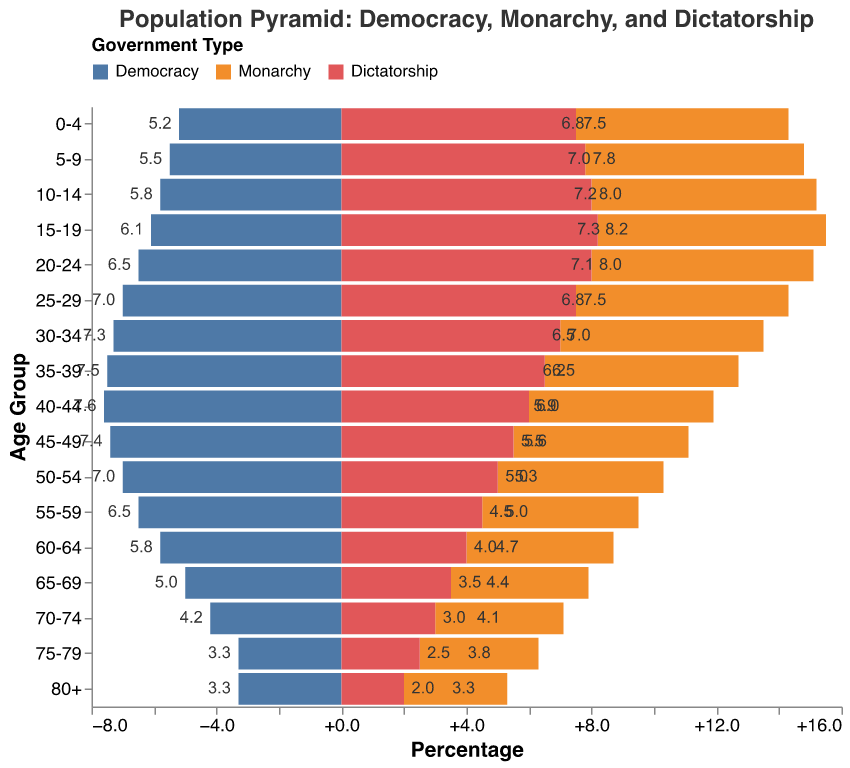What is the title of the figure? The title of the figure is located at the top and typically summarizes the content of the chart in a concise manner.
Answer: Population Pyramid: Democracy, Monarchy, and Dictatorship Which age group has the highest percentage in democracies? To determine this, scan the data values for democracies and identify the maximum.
Answer: 40-44 How does the population structure of dictatorships differ from that of democracies in the age group 0-4? Compare the percentage values for both government types in the age group 0-4.
Answer: Dictatorship: 7.5, Democracy: 5.2 What is the sum of the percentages for ages 70+ in monarchies? Add up the percentages for age groups 70-74, 75-79, and 80+ in monarchies.
Answer: 11.2 Which government type shows a higher percentage in the age group 50-54, Democracy or Dictatorship? Compare the percentages for the age group 50-54 between Democracy and Dictatorship.
Answer: Democracy Is there an age group where the percentage is the same for monarchy and dictatorship? Check each age group and compare the corresponding values for monarchy and dictatorship to find any matches.
Answer: 80+ What is the percentage difference between the 20-24 and 60-64 age groups in dictatorships? Subtract the percentage of the 60-64 age group from the percentage of the 20-24 age group in dictatorships.
Answer: 4.0 How does the percentage of people aged 25-29 in democracies compare to those aged 25-29 in monarchies? Compare the percentage values for the 25-29 age group between democracies and monarchies.
Answer: Democracy: 7.0, Monarchy: 6.8 Which government type shows the lowest percentage in the age group 80+? Identify the lowest percentage for the age group 80+ among the three government types.
Answer: Dictatorship 